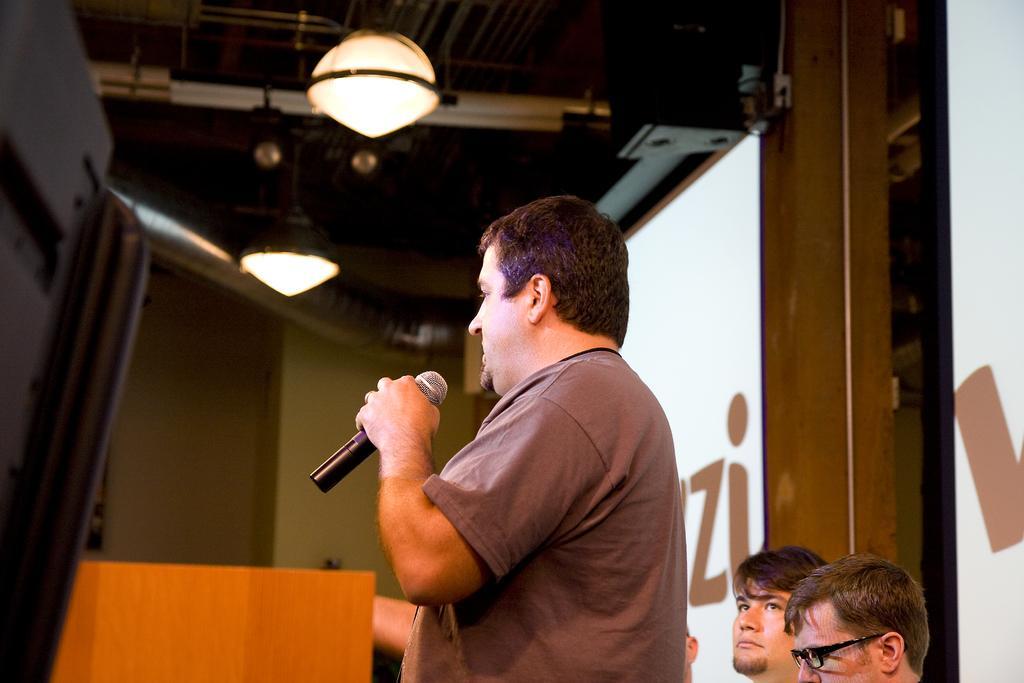How would you summarize this image in a sentence or two? In this image I can see a person standing and holding the mic. At the back there are persons and the screen. In the top there is a light. 